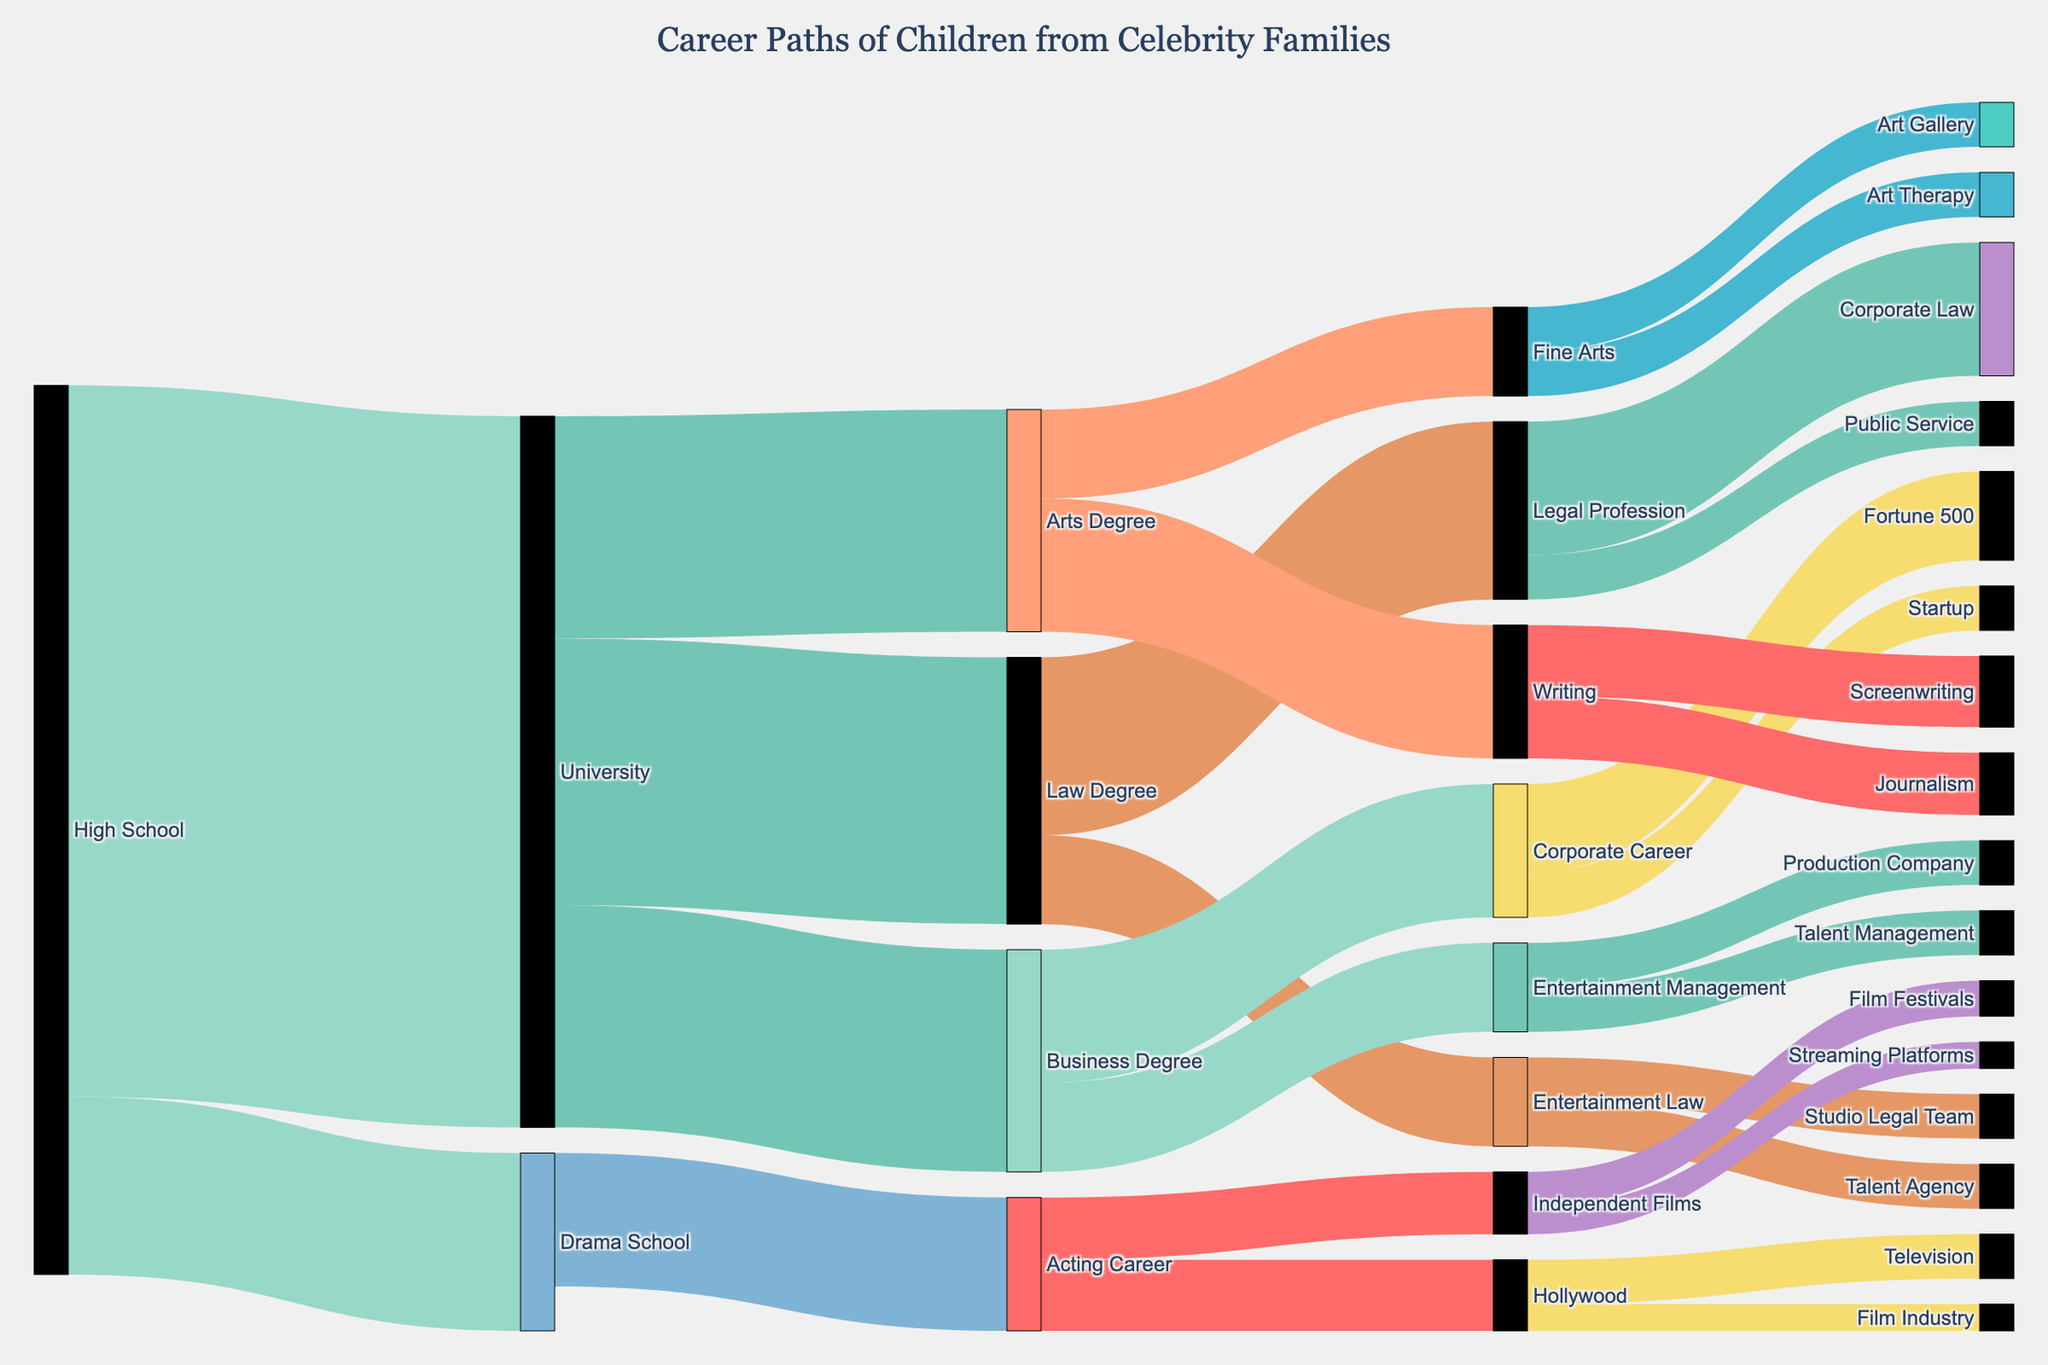How many children transitioned from High School to Drama School? To find this, look at the value of the link connecting High School to Drama School. The value is indicated as "20".
Answer: 20 What career paths do children pursue after obtaining a Law Degree? Observe the links emanating from the "Law Degree" node. They lead to "Legal Profession" (value: 20) and "Entertainment Law" (value: 10) with respective values totaling up to these career paths.
Answer: Legal Profession, Entertainment Law Which sector has the highest number of children directly transitioning to it after University? Examine the values of links from University to different sectors. The Law Degree (value: 30) has the highest single transition value from University.
Answer: Law Degree How many children end up in the Film Industry through the Hollywood path? Follow the path: High School -> Drama School -> Acting Career -> Hollywood -> Film Industry. The value of the final link, Hollywood to Film Industry, is 3.
Answer: 3 Compare the number of children who transitioned from Business Degree to Corporate Career versus those who transitioned from Business Degree to Entertainment Management. From the Business Degree node, 15 go to Corporate Career, and 10 go to Entertainment Management.
Answer: Corporate Career has more transitions (15) than Entertainment Management (10) What are the final career destinations for children who attended Drama School? Follow the paths originating from Drama School. They lead to Acting Career (value: 15), and then further branching into Hollywood and Independent Films.
Answer: Hollywood, Independent Films Calculate the total number of children who transitioned into non-arts related professions directly from University. Sum the values leading from University to Law Degree (30) and Business Degree (25).
Answer: 55 What is the total number of children who pursued any form of law career (either legal profession or entertainment law)? Sum the values for all paths leading to any law career. Law Degree -> Legal Profession (20), Law Degree -> Entertainment Law (10), and Entertainment Law -> Talent Agency (5), Entertainment Law -> Studio Legal Team (5).
Answer: 40 Which field has more children, Journalism or Screenwriting, and by how much? Look at the values leading from the Writing node: Screenwriting (8) and Journalism (7). The difference is 8 - 7.
Answer: Screenwriting by 1 